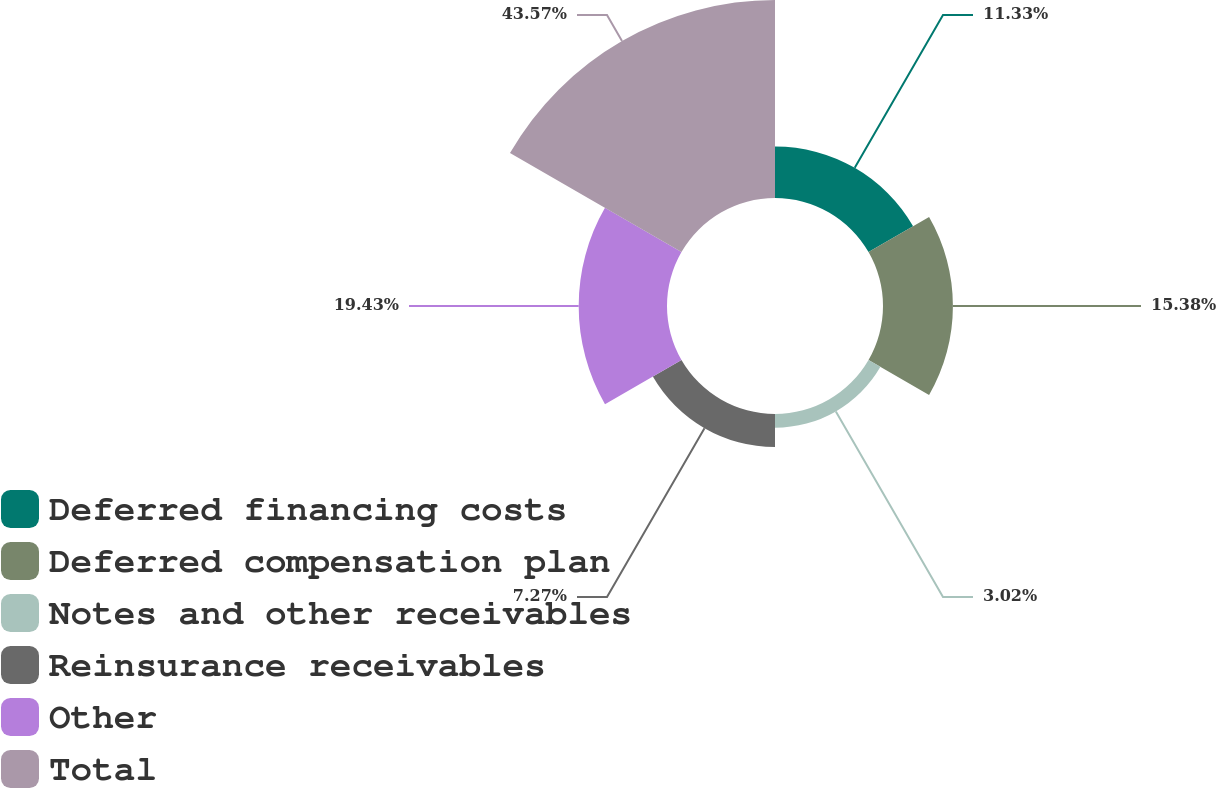<chart> <loc_0><loc_0><loc_500><loc_500><pie_chart><fcel>Deferred financing costs<fcel>Deferred compensation plan<fcel>Notes and other receivables<fcel>Reinsurance receivables<fcel>Other<fcel>Total<nl><fcel>11.33%<fcel>15.38%<fcel>3.02%<fcel>7.27%<fcel>19.43%<fcel>43.56%<nl></chart> 